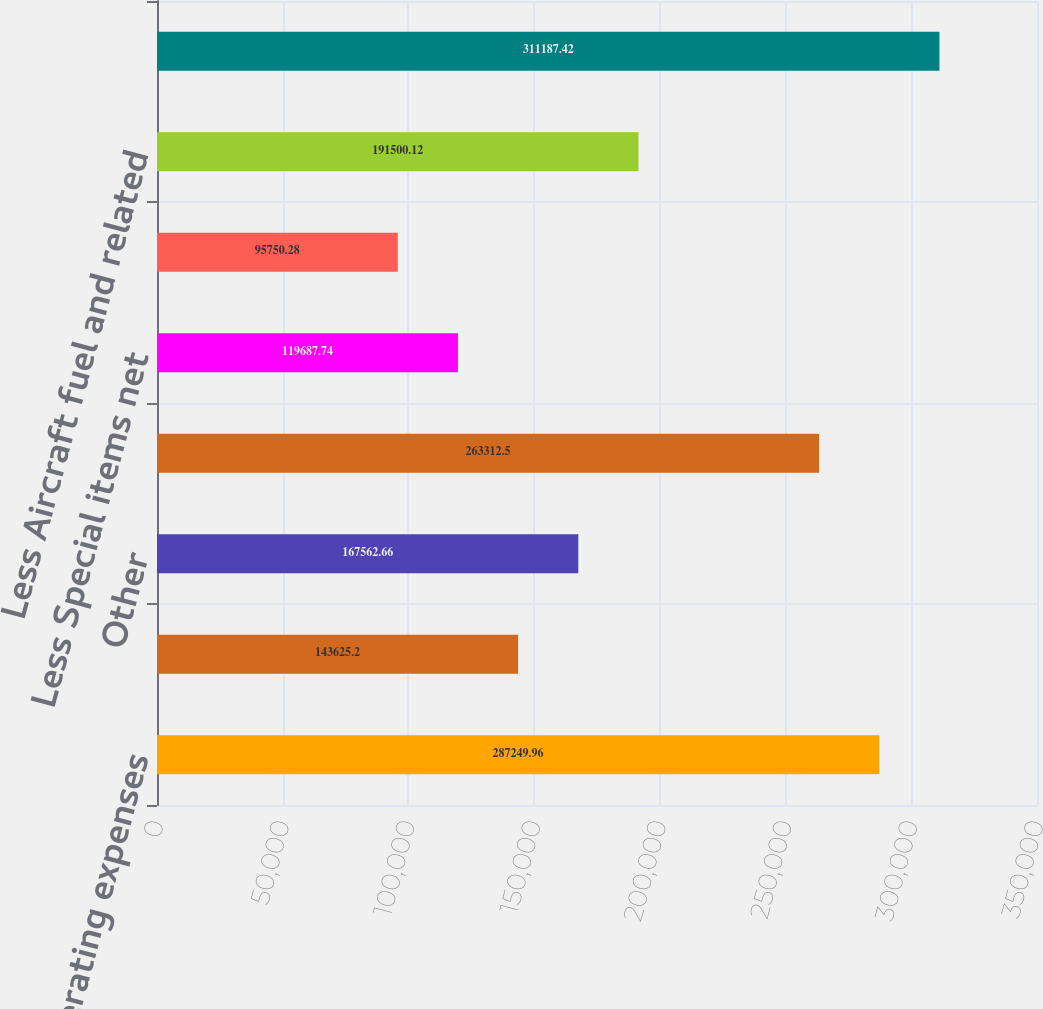<chart> <loc_0><loc_0><loc_500><loc_500><bar_chart><fcel>Total operating expenses<fcel>Fuel<fcel>Other<fcel>Total mainline operating<fcel>Less Special items net<fcel>Mainline operating expenses<fcel>Less Aircraft fuel and related<fcel>Available Seat Miles (ASM)<nl><fcel>287250<fcel>143625<fcel>167563<fcel>263312<fcel>119688<fcel>95750.3<fcel>191500<fcel>311187<nl></chart> 